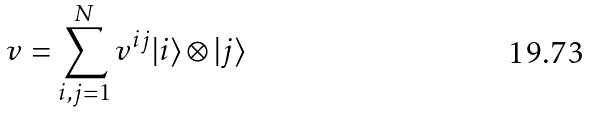Convert formula to latex. <formula><loc_0><loc_0><loc_500><loc_500>v = \sum _ { i , j = 1 } ^ { N } v ^ { i j } | i \rangle \otimes | j \rangle</formula> 